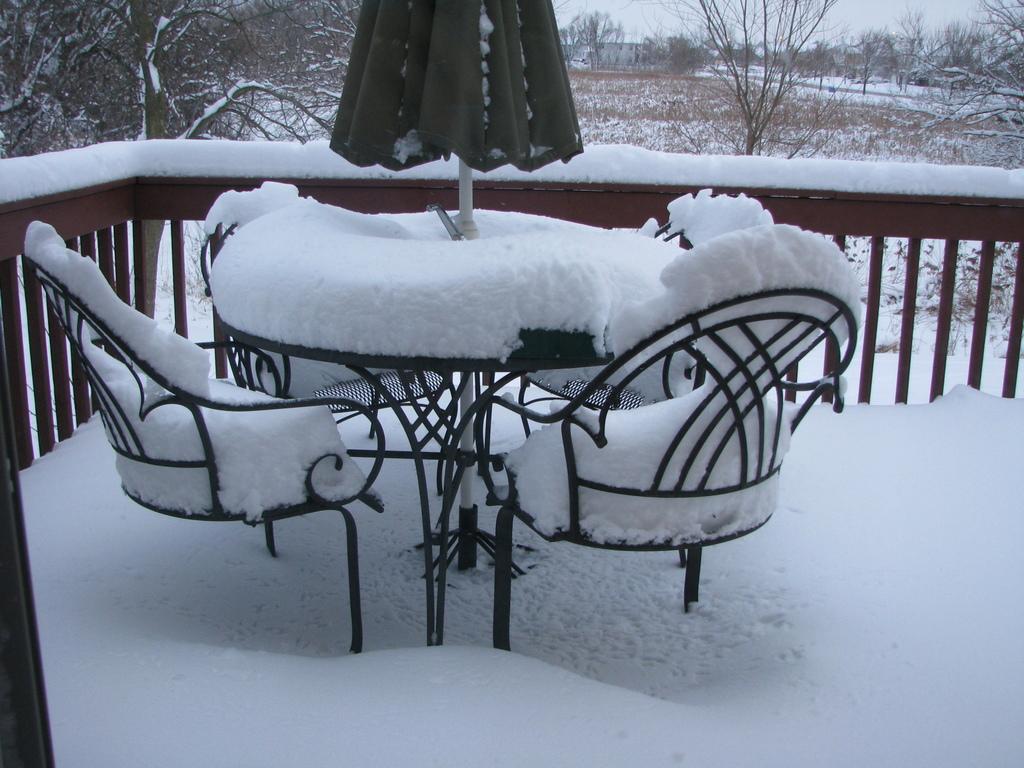How would you summarize this image in a sentence or two? In this image we can see a deck. There is a table and we can see chairs. There is snow and we can see a parasol. In the background there are trees, buildings and sky. 